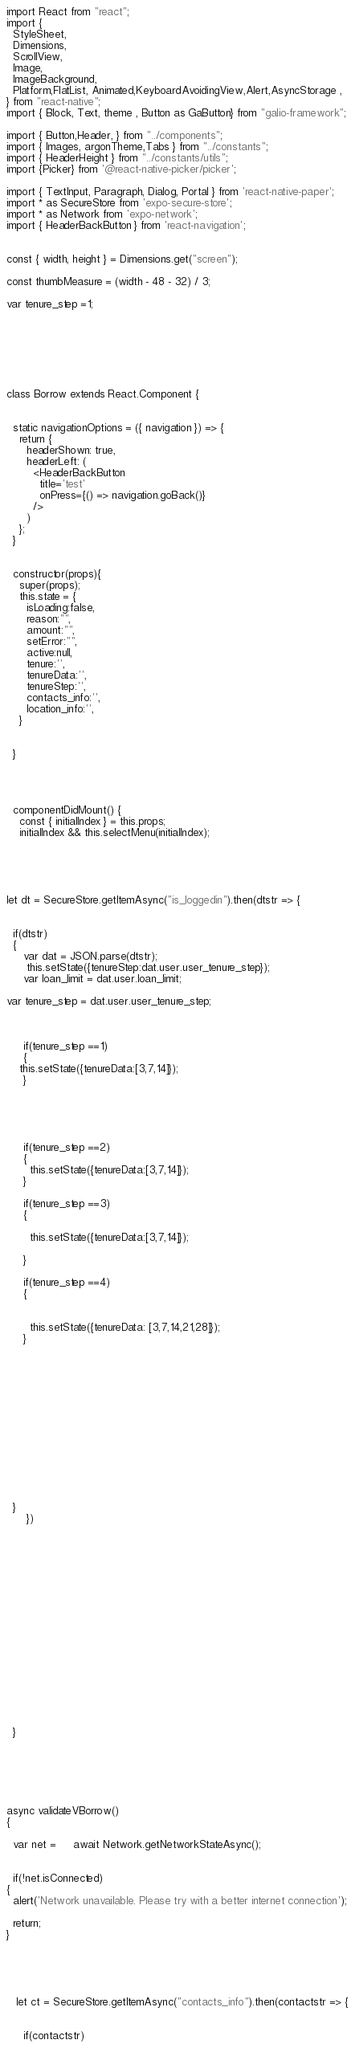Convert code to text. <code><loc_0><loc_0><loc_500><loc_500><_JavaScript_>import React from "react";
import {
  StyleSheet,
  Dimensions,
  ScrollView,
  Image,
  ImageBackground,
  Platform,FlatList, Animated,KeyboardAvoidingView,Alert,AsyncStorage ,
} from "react-native";
import { Block, Text, theme , Button as GaButton} from "galio-framework";

import { Button,Header, } from "../components";
import { Images, argonTheme,Tabs } from "../constants";
import { HeaderHeight } from "../constants/utils";
import {Picker} from '@react-native-picker/picker';

import { TextInput, Paragraph, Dialog, Portal } from 'react-native-paper';
import * as SecureStore from 'expo-secure-store';
import * as Network from 'expo-network';
import { HeaderBackButton } from 'react-navigation';


const { width, height } = Dimensions.get("screen");

const thumbMeasure = (width - 48 - 32) / 3;

var tenure_step =1;







class Borrow extends React.Component {


  static navigationOptions = ({ navigation }) => {
    return {
      headerShown: true,
      headerLeft: (
        <HeaderBackButton
          title='test'
          onPress={() => navigation.goBack()}
        />
      )
    };
  }


  constructor(props){
    super(props);
    this.state = {
      isLoading:false,
      reason:"",
      amount:"",
      setError:"",
      active:null,
      tenure:'',
      tenureData:'',
      tenureStep:'',
      contacts_info:'',
      location_info:'',
    }


  }




  componentDidMount() {
    const { initialIndex } = this.props;
    initialIndex && this.selectMenu(initialIndex);





let dt = SecureStore.getItemAsync("is_loggedin").then(dtstr => {


  if(dtstr)
  {
     var dat = JSON.parse(dtstr);
      this.setState({tenureStep:dat.user.user_tenure_step});
     var loan_limit = dat.user.loan_limit;

var tenure_step = dat.user.user_tenure_step;



     if(tenure_step ==1)
     {
    this.setState({tenureData:[3,7,14]});
     }





     if(tenure_step ==2)
     {
       this.setState({tenureData:[3,7,14]});
     }

     if(tenure_step ==3)
     {

       this.setState({tenureData:[3,7,14]});

     }

     if(tenure_step ==4)
     {


       this.setState({tenureData: [3,7,14,21,28]});
     }














  }
      })


















  }






async validateVBorrow()
{

  var net =     await Network.getNetworkStateAsync();


  if(!net.isConnected)
{
  alert('Network unavailable. Please try with a better internet connection');

  return;
}





   let ct = SecureStore.getItemAsync("contacts_info").then(contactstr => {


     if(contactstr)</code> 